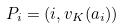Convert formula to latex. <formula><loc_0><loc_0><loc_500><loc_500>P _ { i } = ( i , v _ { K } ( a _ { i } ) )</formula> 